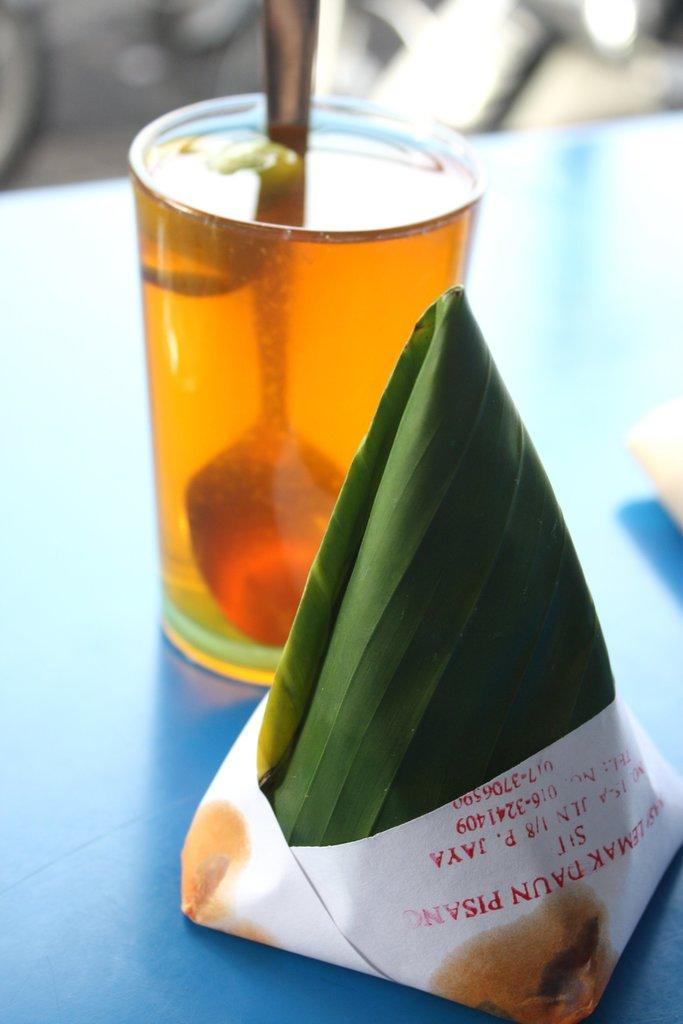What is inside the glass that is visible in the image? There is a drink in the glass that is visible in the image. What utensil is present in the image? There is a spoon in the image. What else can be seen in the image besides the glass and spoon? There is food in the image. Where are the glass, spoon, and food located in the image? The glass, spoon, and food are placed on a table. What type of cork can be seen in the image? There is no cork present in the image. Is there a club visible in the image? There is no club visible in the image. 